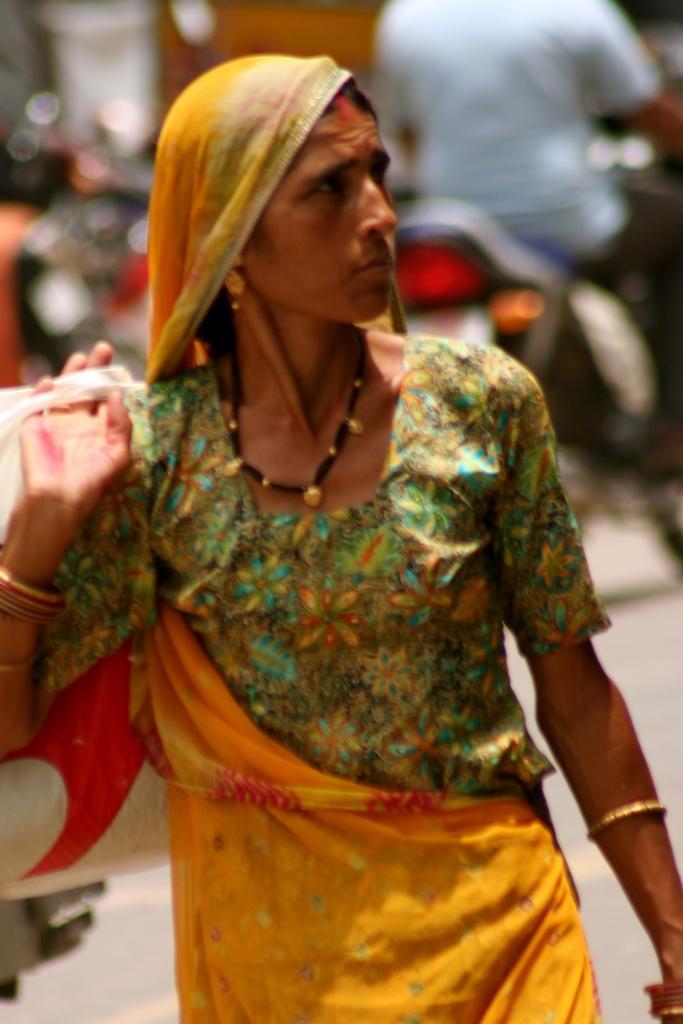In one or two sentences, can you explain what this image depicts? This image is taken outdoors. In this image the background is a little blurred. A bike is parked on the road and a man is riding on the bike. In the middle of the image a woman is walking on the road. She is holding a bag in her hand. 